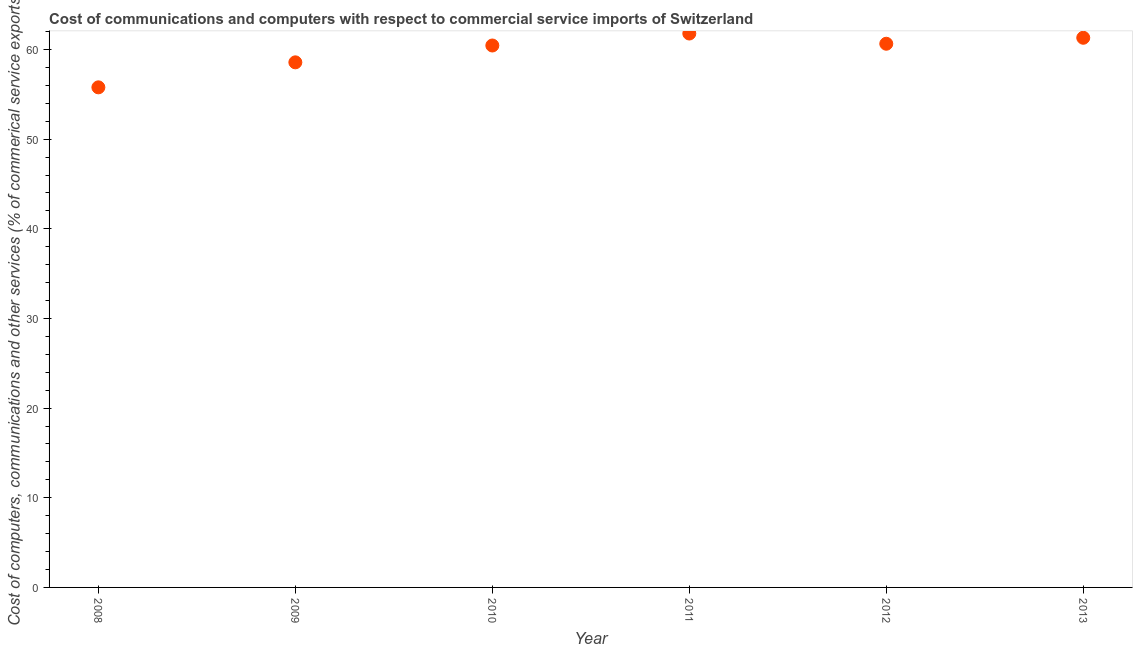What is the cost of communications in 2009?
Your response must be concise. 58.57. Across all years, what is the maximum  computer and other services?
Offer a very short reply. 61.78. Across all years, what is the minimum  computer and other services?
Give a very brief answer. 55.78. What is the sum of the  computer and other services?
Offer a terse response. 358.52. What is the difference between the cost of communications in 2010 and 2012?
Offer a very short reply. -0.2. What is the average  computer and other services per year?
Give a very brief answer. 59.75. What is the median  computer and other services?
Provide a short and direct response. 60.54. In how many years, is the cost of communications greater than 38 %?
Keep it short and to the point. 6. Do a majority of the years between 2009 and 2008 (inclusive) have cost of communications greater than 58 %?
Provide a succinct answer. No. What is the ratio of the cost of communications in 2010 to that in 2011?
Provide a short and direct response. 0.98. What is the difference between the highest and the second highest cost of communications?
Your answer should be compact. 0.47. What is the difference between the highest and the lowest  computer and other services?
Your answer should be compact. 6. Does the cost of communications monotonically increase over the years?
Offer a very short reply. No. Does the graph contain any zero values?
Your response must be concise. No. Does the graph contain grids?
Provide a succinct answer. No. What is the title of the graph?
Your answer should be compact. Cost of communications and computers with respect to commercial service imports of Switzerland. What is the label or title of the X-axis?
Give a very brief answer. Year. What is the label or title of the Y-axis?
Give a very brief answer. Cost of computers, communications and other services (% of commerical service exports). What is the Cost of computers, communications and other services (% of commerical service exports) in 2008?
Your answer should be very brief. 55.78. What is the Cost of computers, communications and other services (% of commerical service exports) in 2009?
Your response must be concise. 58.57. What is the Cost of computers, communications and other services (% of commerical service exports) in 2010?
Provide a succinct answer. 60.44. What is the Cost of computers, communications and other services (% of commerical service exports) in 2011?
Keep it short and to the point. 61.78. What is the Cost of computers, communications and other services (% of commerical service exports) in 2012?
Ensure brevity in your answer.  60.64. What is the Cost of computers, communications and other services (% of commerical service exports) in 2013?
Make the answer very short. 61.31. What is the difference between the Cost of computers, communications and other services (% of commerical service exports) in 2008 and 2009?
Make the answer very short. -2.79. What is the difference between the Cost of computers, communications and other services (% of commerical service exports) in 2008 and 2010?
Provide a succinct answer. -4.67. What is the difference between the Cost of computers, communications and other services (% of commerical service exports) in 2008 and 2011?
Your answer should be very brief. -6. What is the difference between the Cost of computers, communications and other services (% of commerical service exports) in 2008 and 2012?
Your answer should be compact. -4.86. What is the difference between the Cost of computers, communications and other services (% of commerical service exports) in 2008 and 2013?
Keep it short and to the point. -5.53. What is the difference between the Cost of computers, communications and other services (% of commerical service exports) in 2009 and 2010?
Provide a succinct answer. -1.88. What is the difference between the Cost of computers, communications and other services (% of commerical service exports) in 2009 and 2011?
Ensure brevity in your answer.  -3.21. What is the difference between the Cost of computers, communications and other services (% of commerical service exports) in 2009 and 2012?
Offer a very short reply. -2.07. What is the difference between the Cost of computers, communications and other services (% of commerical service exports) in 2009 and 2013?
Your answer should be compact. -2.74. What is the difference between the Cost of computers, communications and other services (% of commerical service exports) in 2010 and 2011?
Your response must be concise. -1.34. What is the difference between the Cost of computers, communications and other services (% of commerical service exports) in 2010 and 2012?
Offer a very short reply. -0.2. What is the difference between the Cost of computers, communications and other services (% of commerical service exports) in 2010 and 2013?
Provide a succinct answer. -0.86. What is the difference between the Cost of computers, communications and other services (% of commerical service exports) in 2011 and 2012?
Ensure brevity in your answer.  1.14. What is the difference between the Cost of computers, communications and other services (% of commerical service exports) in 2011 and 2013?
Offer a terse response. 0.47. What is the difference between the Cost of computers, communications and other services (% of commerical service exports) in 2012 and 2013?
Ensure brevity in your answer.  -0.67. What is the ratio of the Cost of computers, communications and other services (% of commerical service exports) in 2008 to that in 2010?
Keep it short and to the point. 0.92. What is the ratio of the Cost of computers, communications and other services (% of commerical service exports) in 2008 to that in 2011?
Offer a terse response. 0.9. What is the ratio of the Cost of computers, communications and other services (% of commerical service exports) in 2008 to that in 2013?
Provide a short and direct response. 0.91. What is the ratio of the Cost of computers, communications and other services (% of commerical service exports) in 2009 to that in 2010?
Your answer should be very brief. 0.97. What is the ratio of the Cost of computers, communications and other services (% of commerical service exports) in 2009 to that in 2011?
Ensure brevity in your answer.  0.95. What is the ratio of the Cost of computers, communications and other services (% of commerical service exports) in 2009 to that in 2012?
Provide a succinct answer. 0.97. What is the ratio of the Cost of computers, communications and other services (% of commerical service exports) in 2009 to that in 2013?
Your answer should be compact. 0.95. What is the ratio of the Cost of computers, communications and other services (% of commerical service exports) in 2010 to that in 2011?
Offer a very short reply. 0.98. What is the ratio of the Cost of computers, communications and other services (% of commerical service exports) in 2010 to that in 2013?
Offer a very short reply. 0.99. What is the ratio of the Cost of computers, communications and other services (% of commerical service exports) in 2011 to that in 2012?
Offer a terse response. 1.02. What is the ratio of the Cost of computers, communications and other services (% of commerical service exports) in 2011 to that in 2013?
Give a very brief answer. 1.01. What is the ratio of the Cost of computers, communications and other services (% of commerical service exports) in 2012 to that in 2013?
Offer a terse response. 0.99. 